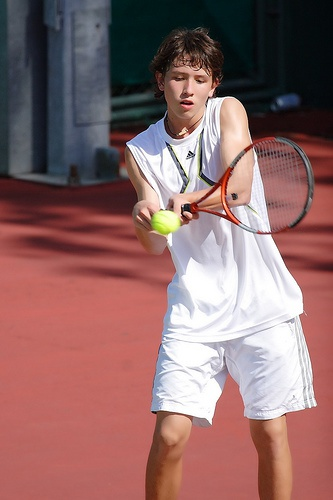Describe the objects in this image and their specific colors. I can see people in black, white, brown, darkgray, and maroon tones, tennis racket in black, brown, lavender, tan, and gray tones, and sports ball in black, khaki, lightyellow, and olive tones in this image. 